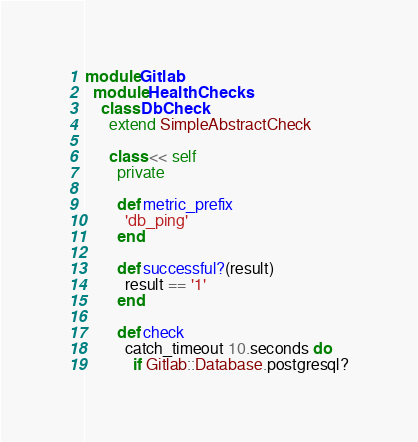Convert code to text. <code><loc_0><loc_0><loc_500><loc_500><_Ruby_>module Gitlab
  module HealthChecks
    class DbCheck
      extend SimpleAbstractCheck

      class << self
        private

        def metric_prefix
          'db_ping'
        end

        def successful?(result)
          result == '1'
        end

        def check
          catch_timeout 10.seconds do
            if Gitlab::Database.postgresql?</code> 